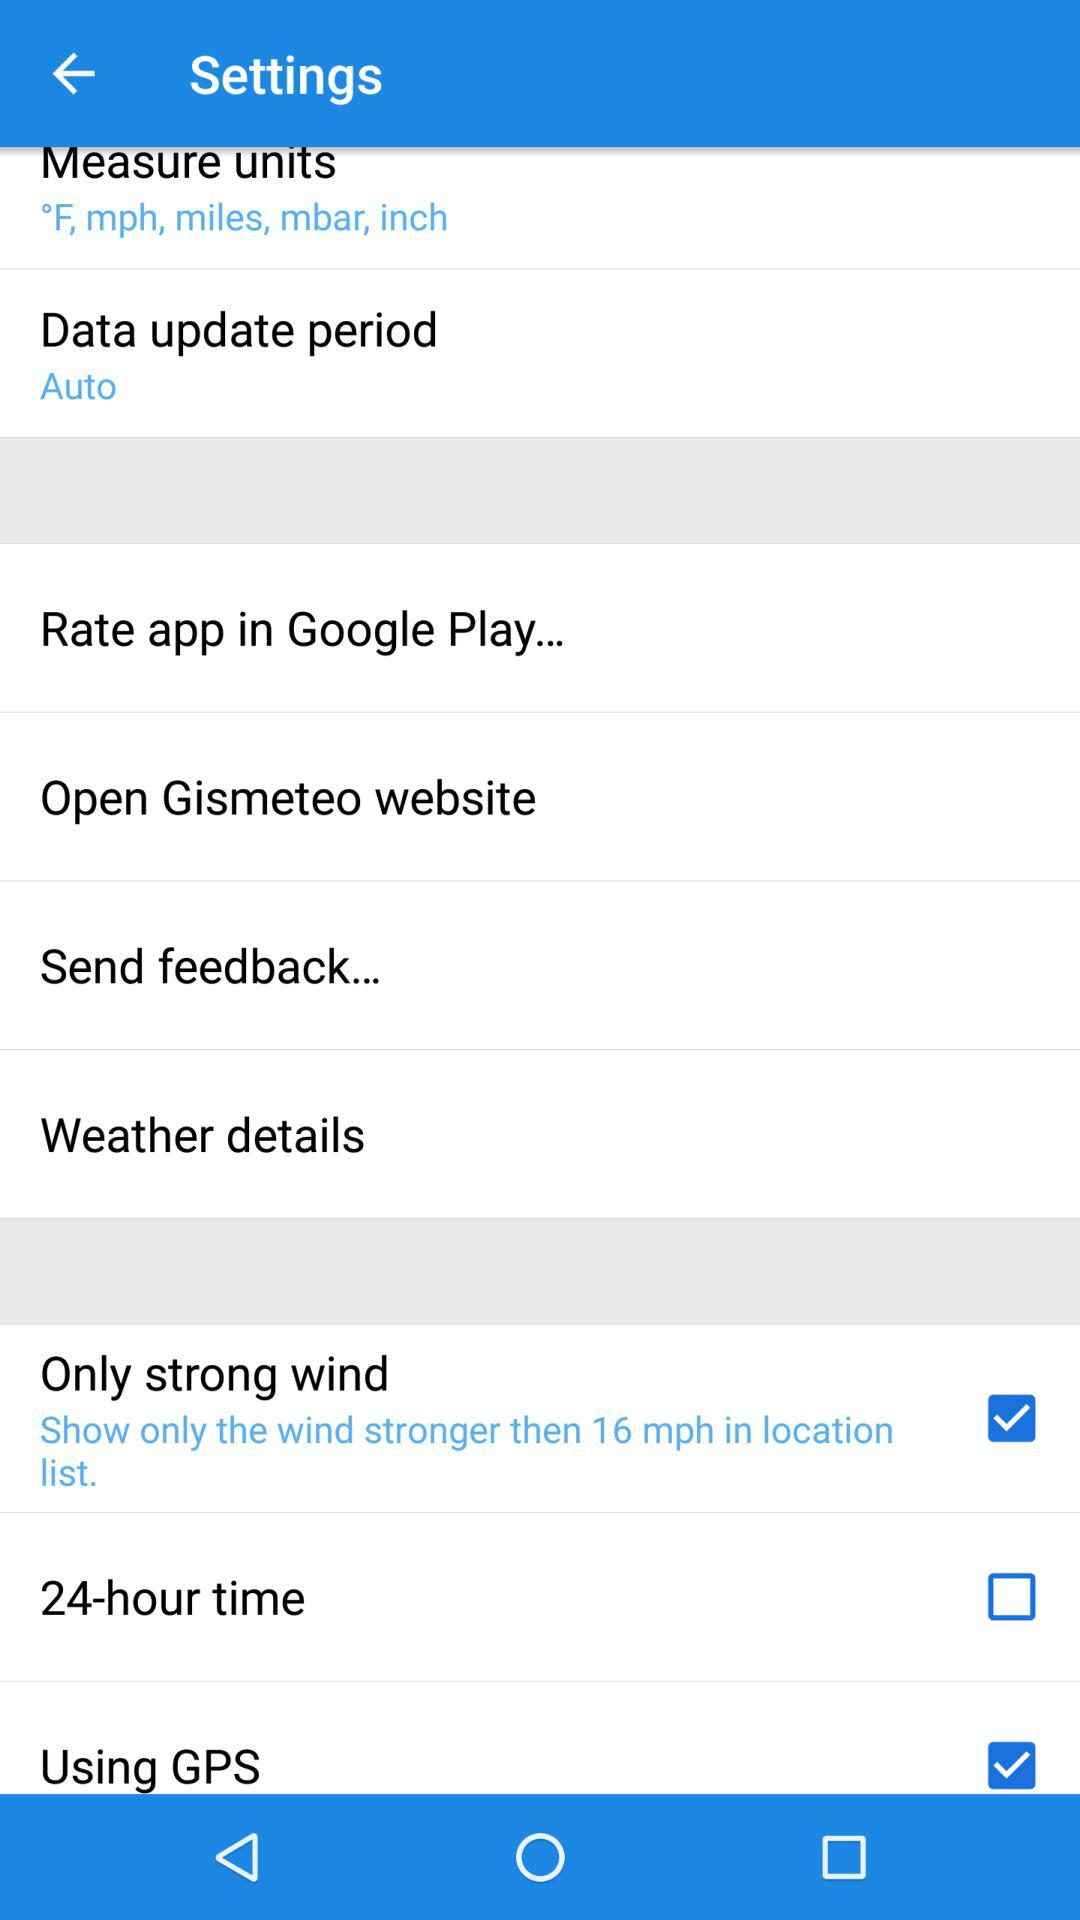What are the measuring units? The measuring units are °F, mph, miles, mbar and inch. 